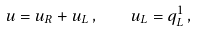<formula> <loc_0><loc_0><loc_500><loc_500>u = u _ { R } + u _ { L } \, , \quad u _ { L } = q _ { L } ^ { 1 } \, ,</formula> 